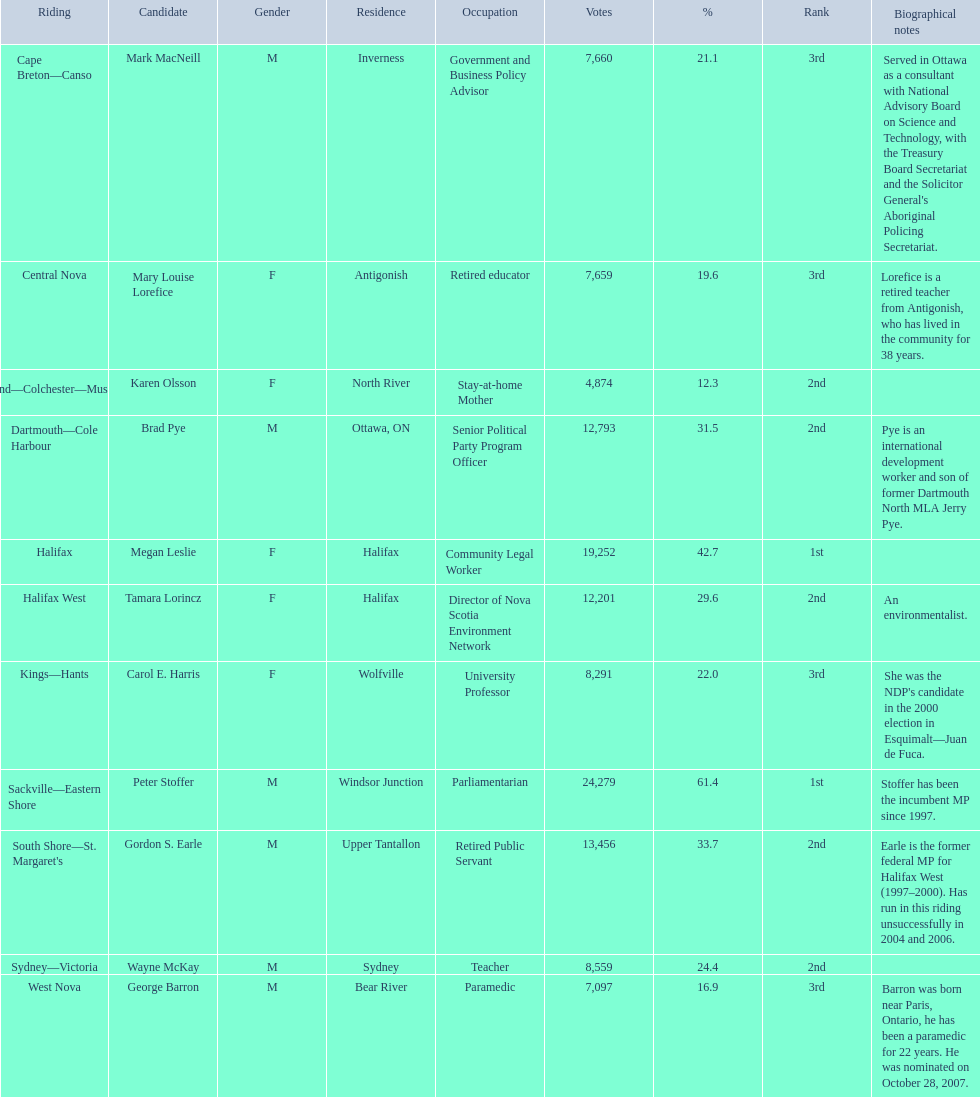Who were all of the new democratic party candidates during the 2008 canadian federal election? Mark MacNeill, Mary Louise Lorefice, Karen Olsson, Brad Pye, Megan Leslie, Tamara Lorincz, Carol E. Harris, Peter Stoffer, Gordon S. Earle, Wayne McKay, George Barron. And between mark macneill and karen olsson, which candidate received more votes? Mark MacNeill. 